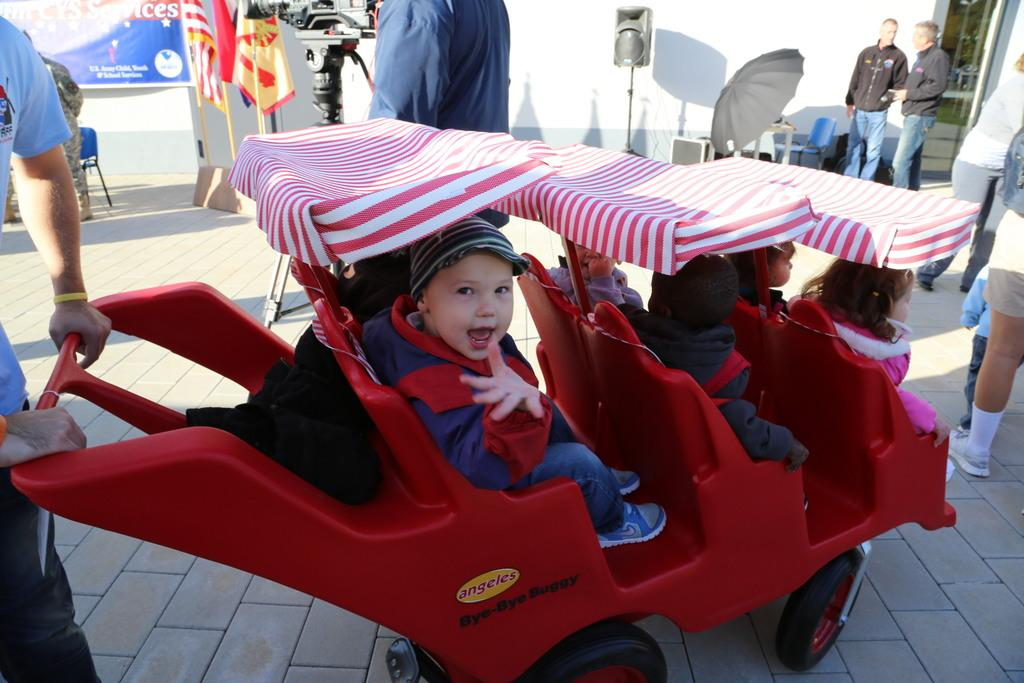What is the main object in the image? There is a vehicle in the image. What else can be seen in the image besides the vehicle? There is a banner, a white color wall, flags, people, a sound box, a chair, and an umbrella in the image. What type of decorations are present in the image? There are flags and a banner in the image. What might be used for seating in the image? There is a chair in the image for seating. Can you see a cat wearing a hat in the image? There is no cat or hat present in the image. Is there a plant growing on the white color wall in the image? There is no plant visible on the white color wall in the image. 